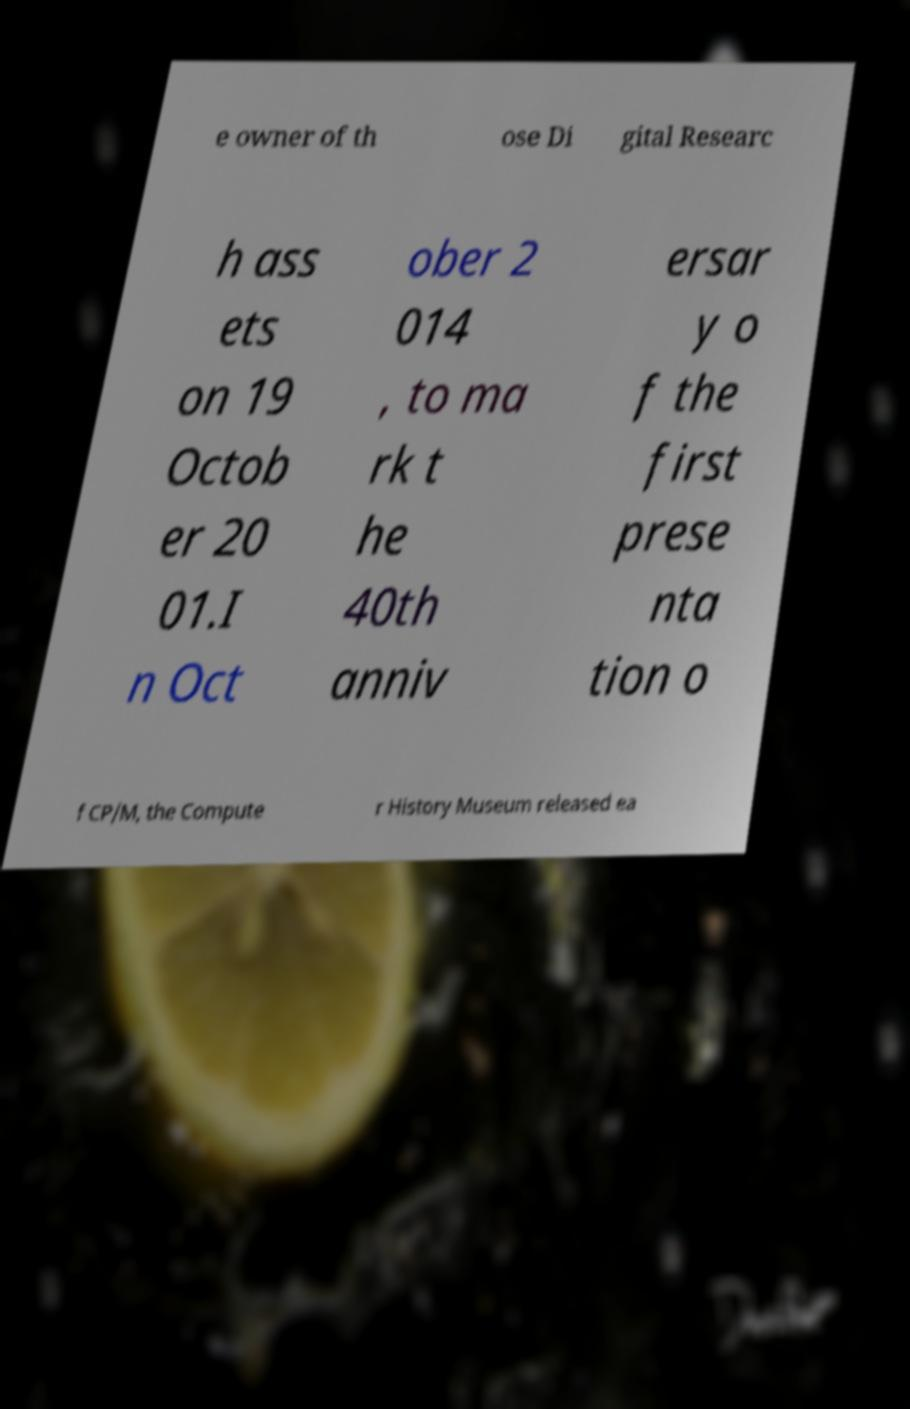I need the written content from this picture converted into text. Can you do that? e owner of th ose Di gital Researc h ass ets on 19 Octob er 20 01.I n Oct ober 2 014 , to ma rk t he 40th anniv ersar y o f the first prese nta tion o f CP/M, the Compute r History Museum released ea 